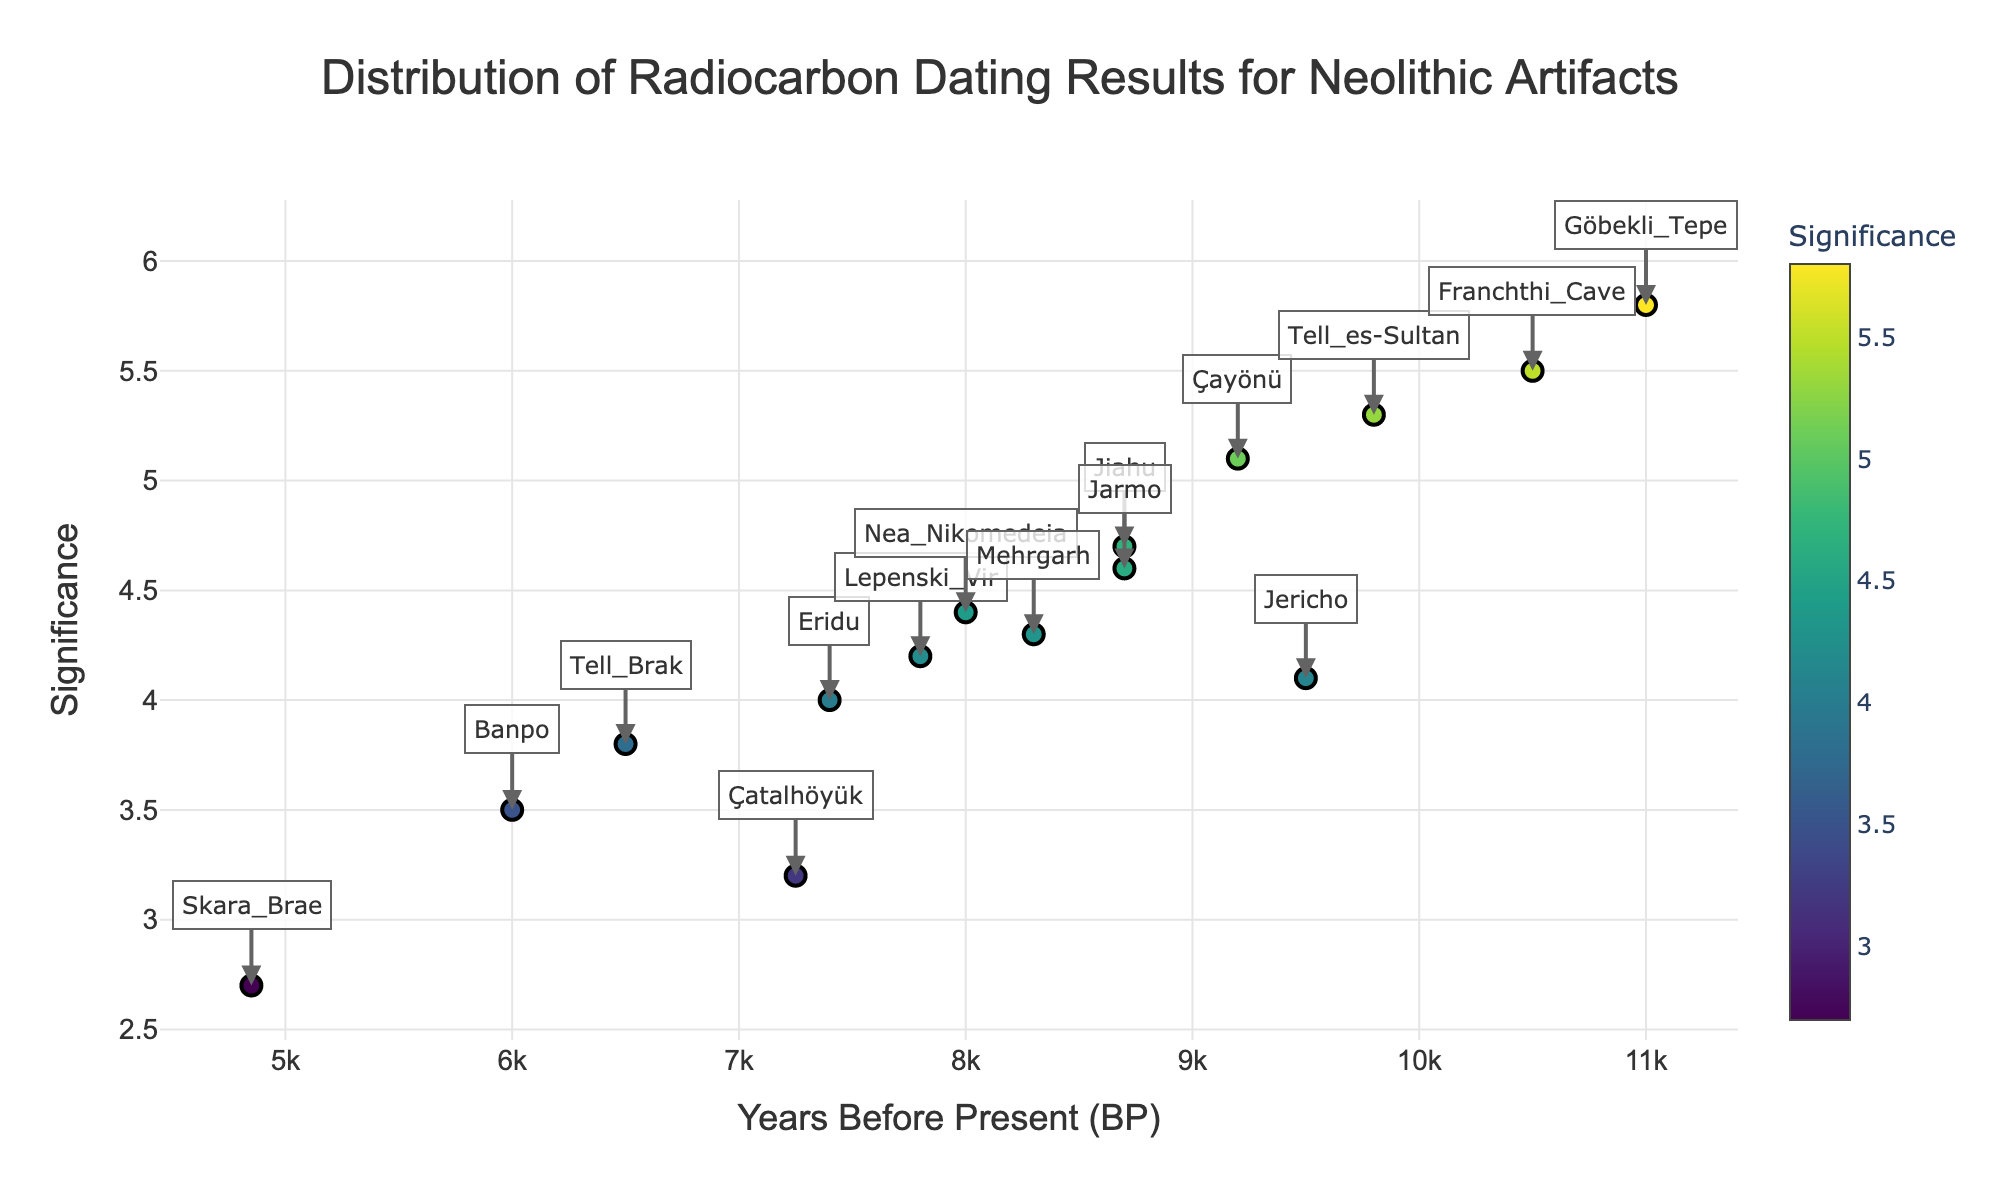What is the title of the plot? The title is located at the top of the plot and it can be read directly. It summarizes the main theme of the plot, which is: "Distribution of Radiocarbon Dating Results for Neolithic Artifacts"
Answer: Distribution of Radiocarbon Dating Results for Neolithic Artifacts Which artifact type has the highest significance? The highest significance point on the y-axis can be identified visually. By checking the data label, we observe that the artifact type "Carved Pillars" from Göbekli Tepe has the highest significance value of 5.8.
Answer: Carved Pillars What range of years does the plot cover? By checking the x-axis which represents the "Years Before Present (BP)", we find that the years range from the lowest value of 4850 to the highest value of 11000 years BP.
Answer: 4850 to 11000 years BP How many artifacts have a significance score greater than 5? We count the data points that have a y-axis value greater than 5. These artifacts are: Carved Pillars (5.8), Shell Beads (5.5), Woven Textiles (5.3), and Copper Beads (5.1).
Answer: 4 What is the significance value of the oldest artifact? By identifying the oldest artifact on the x-axis (Years BP) and checking its corresponding y-axis value, we find that the Carved Pillars from Göbekli Tepe (11000 years BP) has a significance value of 5.8.
Answer: 5.8 Which site has the artifact with the lowest significance? The lowest point on the y-axis represents the artifact with the lowest significance value. By checking the data label, we find that the Bone Implements from Skara Brae has the lowest significance of 2.7.
Answer: Skara Brae What are the average years BP of all artifacts? Sum all the provided "Years BP" values: (7250 + 9500 + 11000 + 4850 + 6000 + 8300 + 8700 + 6500 + 7400 + 9200 + 7800 + 10500 + 8000 + 9800 + 8700) = 133,500. Divide by the number of artifacts (15): 133,500 / 15 = 8,900 years BP.
Answer: 8,900 years BP Which site has artifacts closest to 9000 years BP? By examining the x-axis around 9000 years BP within the plot and checking the data labels, we identify Jarmo (Stone Bowls, 8700 years BP) and Çayönü (Copper Beads, 9200 years BP) close to this range.
Answer: Jarmo and Çayönü How many sites have artifacts dating back more than 8000 years BP? Count the data points on the x-axis greater than 8000 years BP. These sites/artifacts are: Jericho (9500), Göbekli Tepe (11000), Mehrgarh (8300), Jiahu (8700), Franchthi Cave (10500), Çayönü (9200), Tell_es-Sultan (9800), and Jarmo (8700).
Answer: 8 Which artifact has a significance value of exactly 4.0? By examining the y-axis and finding the data point with a significance of 4.0, we see that the Clay Tablets from Eridu have this exact value.
Answer: Clay Tablets 